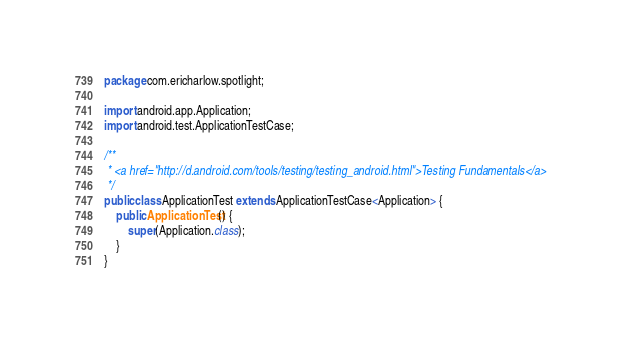<code> <loc_0><loc_0><loc_500><loc_500><_Java_>package com.ericharlow.spotlight;

import android.app.Application;
import android.test.ApplicationTestCase;

/**
 * <a href="http://d.android.com/tools/testing/testing_android.html">Testing Fundamentals</a>
 */
public class ApplicationTest extends ApplicationTestCase<Application> {
    public ApplicationTest() {
        super(Application.class);
    }
}</code> 